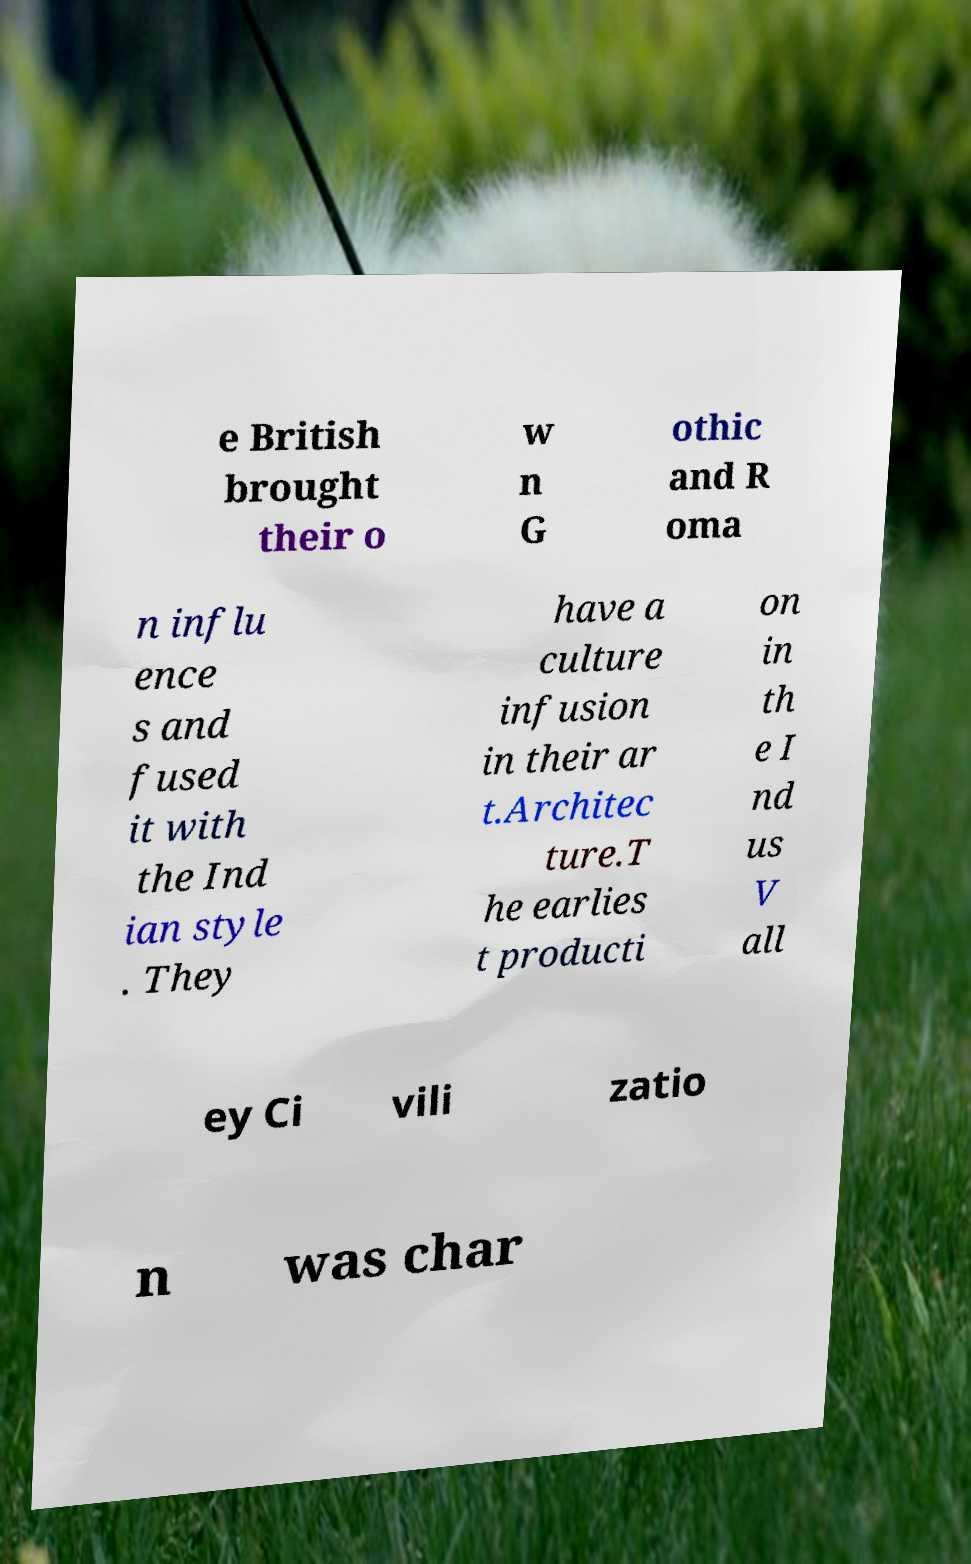Can you read and provide the text displayed in the image?This photo seems to have some interesting text. Can you extract and type it out for me? e British brought their o w n G othic and R oma n influ ence s and fused it with the Ind ian style . They have a culture infusion in their ar t.Architec ture.T he earlies t producti on in th e I nd us V all ey Ci vili zatio n was char 